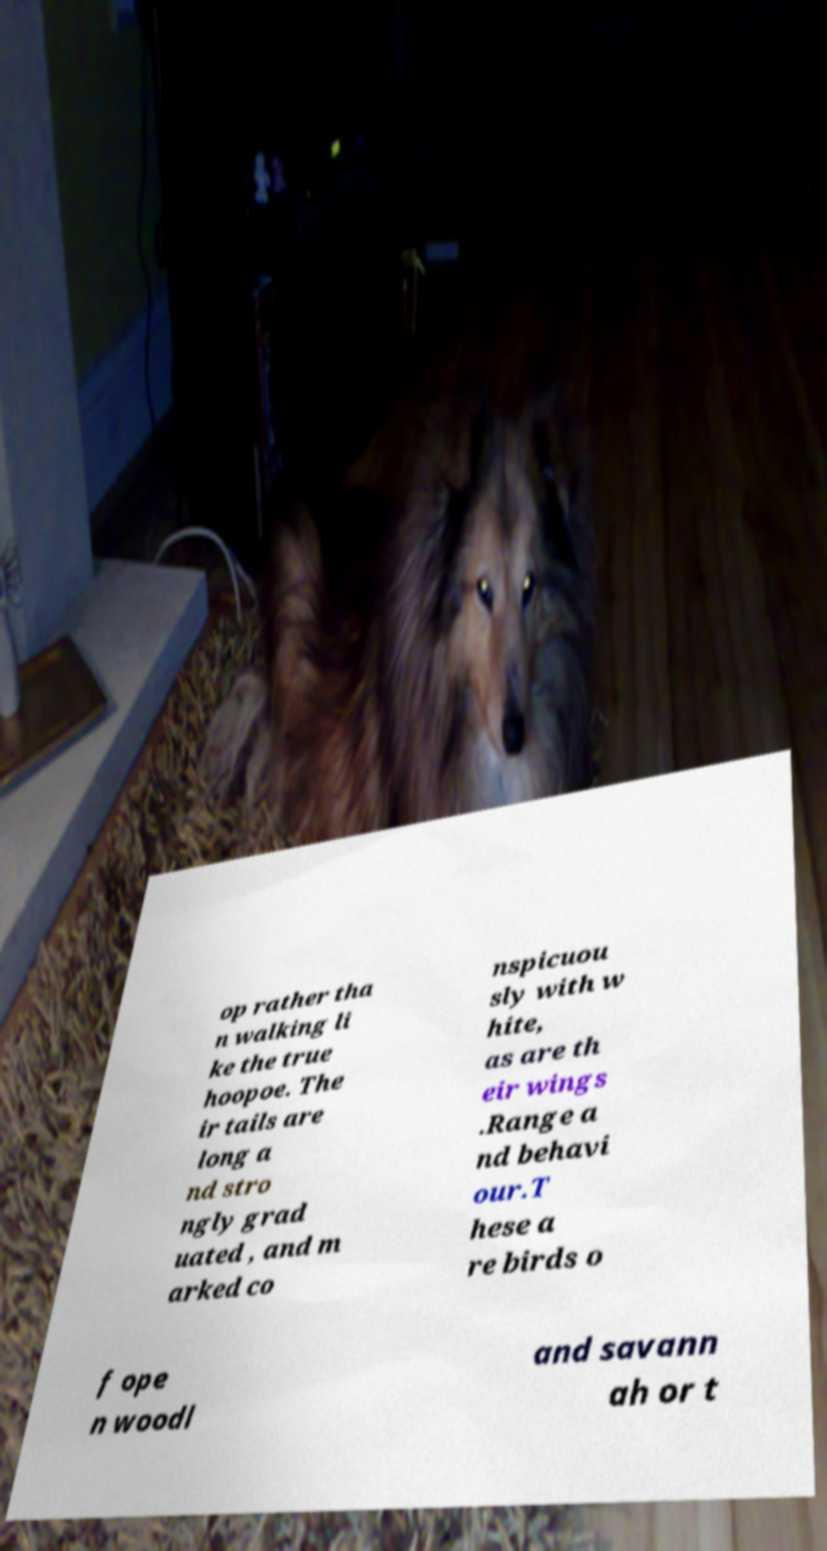What messages or text are displayed in this image? I need them in a readable, typed format. op rather tha n walking li ke the true hoopoe. The ir tails are long a nd stro ngly grad uated , and m arked co nspicuou sly with w hite, as are th eir wings .Range a nd behavi our.T hese a re birds o f ope n woodl and savann ah or t 